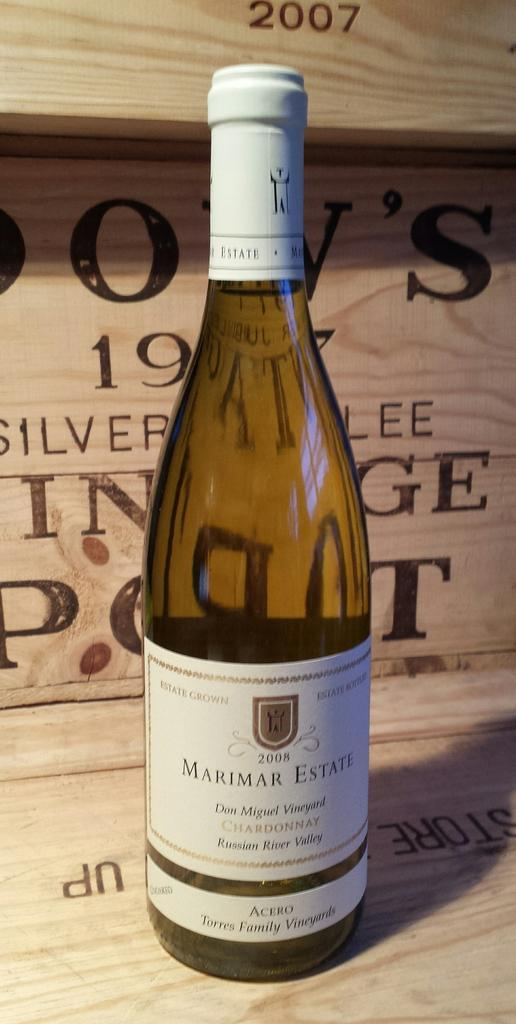<image>
Present a compact description of the photo's key features. A classic glass bottle of 2008 Marimar Estate 